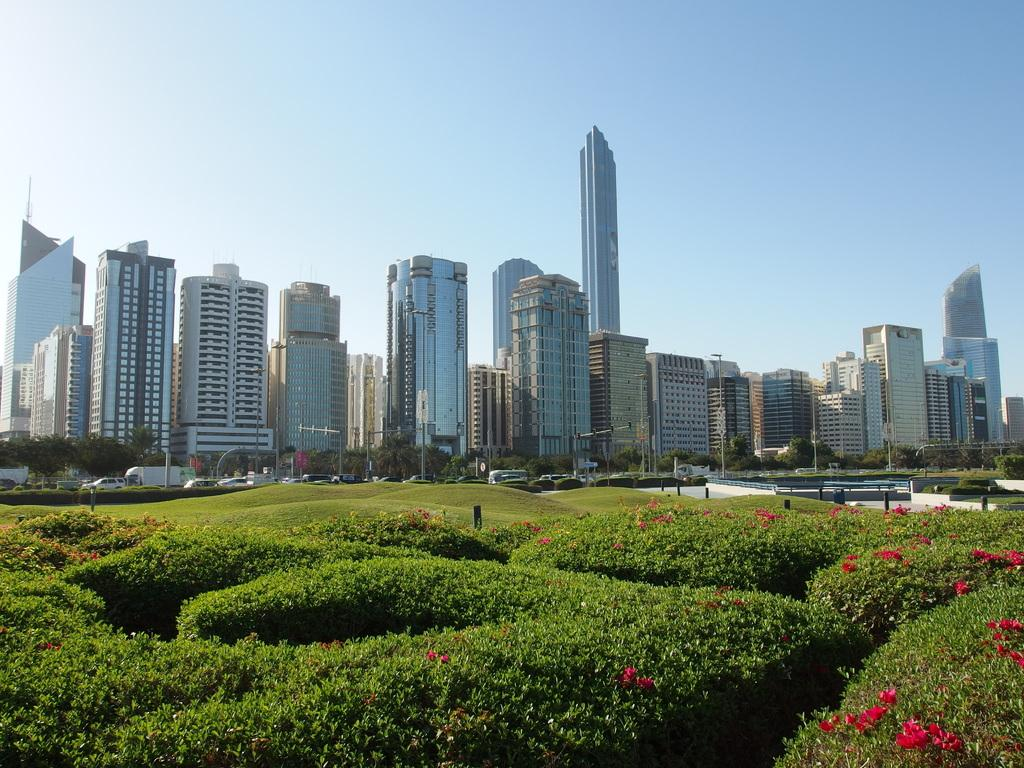What type of plants can be seen in the image? There are plants with flowers in the image. What can be seen in the background of the image? There are buildings, cars, traffic poles, grass, and the sky visible in the background of the image. What type of wire can be seen connecting the plants in the image? There is no wire connecting the plants in the image; the plants are separate and not connected. 